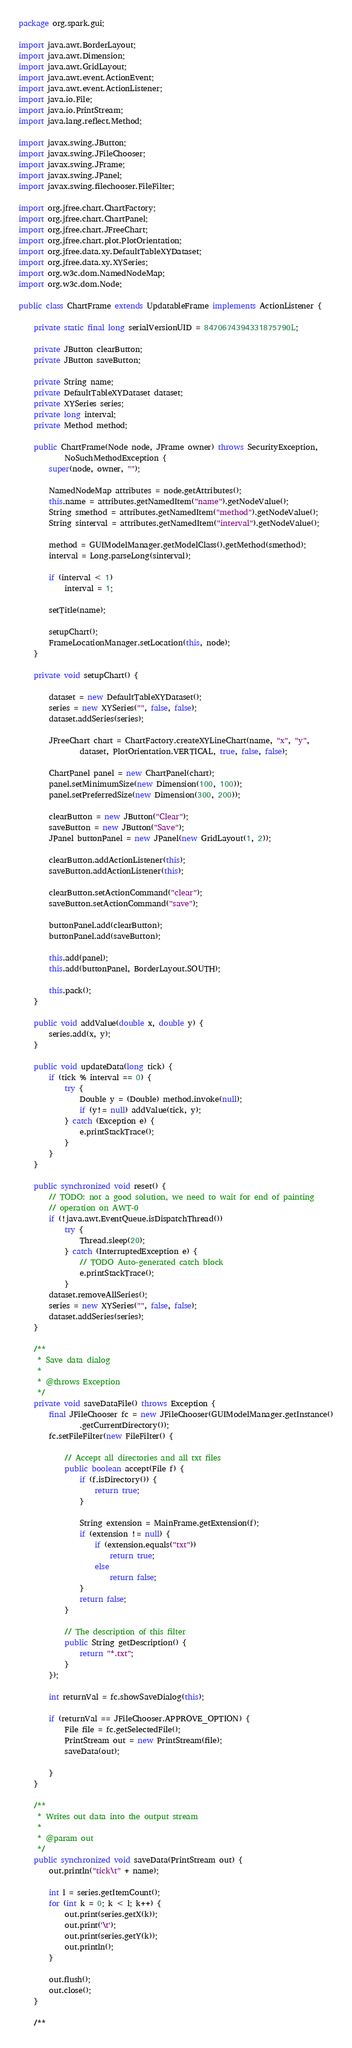Convert code to text. <code><loc_0><loc_0><loc_500><loc_500><_Java_>package org.spark.gui;

import java.awt.BorderLayout;
import java.awt.Dimension;
import java.awt.GridLayout;
import java.awt.event.ActionEvent;
import java.awt.event.ActionListener;
import java.io.File;
import java.io.PrintStream;
import java.lang.reflect.Method;

import javax.swing.JButton;
import javax.swing.JFileChooser;
import javax.swing.JFrame;
import javax.swing.JPanel;
import javax.swing.filechooser.FileFilter;

import org.jfree.chart.ChartFactory;
import org.jfree.chart.ChartPanel;
import org.jfree.chart.JFreeChart;
import org.jfree.chart.plot.PlotOrientation;
import org.jfree.data.xy.DefaultTableXYDataset;
import org.jfree.data.xy.XYSeries;
import org.w3c.dom.NamedNodeMap;
import org.w3c.dom.Node;

public class ChartFrame extends UpdatableFrame implements ActionListener {

	private static final long serialVersionUID = 8470674394331875790L;

	private JButton clearButton;
	private JButton saveButton;

	private String name;
	private DefaultTableXYDataset dataset;
	private XYSeries series;
	private long interval;
	private Method method;

	public ChartFrame(Node node, JFrame owner) throws SecurityException,
			NoSuchMethodException {
		super(node, owner, "");

		NamedNodeMap attributes = node.getAttributes();
		this.name = attributes.getNamedItem("name").getNodeValue();
		String smethod = attributes.getNamedItem("method").getNodeValue();
		String sinterval = attributes.getNamedItem("interval").getNodeValue();

		method = GUIModelManager.getModelClass().getMethod(smethod);
		interval = Long.parseLong(sinterval);
		
		if (interval < 1)
			interval = 1;

		setTitle(name);

		setupChart();
		FrameLocationManager.setLocation(this, node);
	}

	private void setupChart() {

		dataset = new DefaultTableXYDataset();
		series = new XYSeries("", false, false);
		dataset.addSeries(series);

		JFreeChart chart = ChartFactory.createXYLineChart(name, "x", "y",
				dataset, PlotOrientation.VERTICAL, true, false, false);
		
		ChartPanel panel = new ChartPanel(chart);
		panel.setMinimumSize(new Dimension(100, 100));
		panel.setPreferredSize(new Dimension(300, 200));

		clearButton = new JButton("Clear");
		saveButton = new JButton("Save");
		JPanel buttonPanel = new JPanel(new GridLayout(1, 2));

		clearButton.addActionListener(this);
		saveButton.addActionListener(this);

		clearButton.setActionCommand("clear");
		saveButton.setActionCommand("save");

		buttonPanel.add(clearButton);
		buttonPanel.add(saveButton);

		this.add(panel);
		this.add(buttonPanel, BorderLayout.SOUTH);

		this.pack();
	}

	public void addValue(double x, double y) {
		series.add(x, y);
	}

	public void updateData(long tick) {
		if (tick % interval == 0) {
			try {
				Double y = (Double) method.invoke(null);
				if (y!= null) addValue(tick, y);
			} catch (Exception e) {
				e.printStackTrace();
			}
		}
	}

	public synchronized void reset() {
		// TODO: not a good solution, we need to wait for end of painting
		// operation on AWT-0
		if (!java.awt.EventQueue.isDispatchThread())
			try {
				Thread.sleep(20);
			} catch (InterruptedException e) {
				// TODO Auto-generated catch block
				e.printStackTrace();
			}
		dataset.removeAllSeries();
		series = new XYSeries("", false, false);
		dataset.addSeries(series);
	}

	/**
	 * Save data dialog
	 * 
	 * @throws Exception
	 */
	private void saveDataFile() throws Exception {
		final JFileChooser fc = new JFileChooser(GUIModelManager.getInstance()
				.getCurrentDirectory());
		fc.setFileFilter(new FileFilter() {

			// Accept all directories and all txt files
			public boolean accept(File f) {
				if (f.isDirectory()) {
					return true;
				}

				String extension = MainFrame.getExtension(f);
				if (extension != null) {
					if (extension.equals("txt"))
						return true;
					else
						return false;
				}
				return false;
			}

			// The description of this filter
			public String getDescription() {
				return "*.txt";
			}
		});

		int returnVal = fc.showSaveDialog(this);

		if (returnVal == JFileChooser.APPROVE_OPTION) {
			File file = fc.getSelectedFile();
			PrintStream out = new PrintStream(file);
			saveData(out);

		}
	}

	/**
	 * Writes out data into the output stream
	 * 
	 * @param out
	 */
	public synchronized void saveData(PrintStream out) {
		out.println("tick\t" + name);

		int l = series.getItemCount();
		for (int k = 0; k < l; k++) {
			out.print(series.getX(k));
			out.print('\t');
			out.print(series.getY(k));
			out.println();
		}

		out.flush();
		out.close();
	}

	/**</code> 